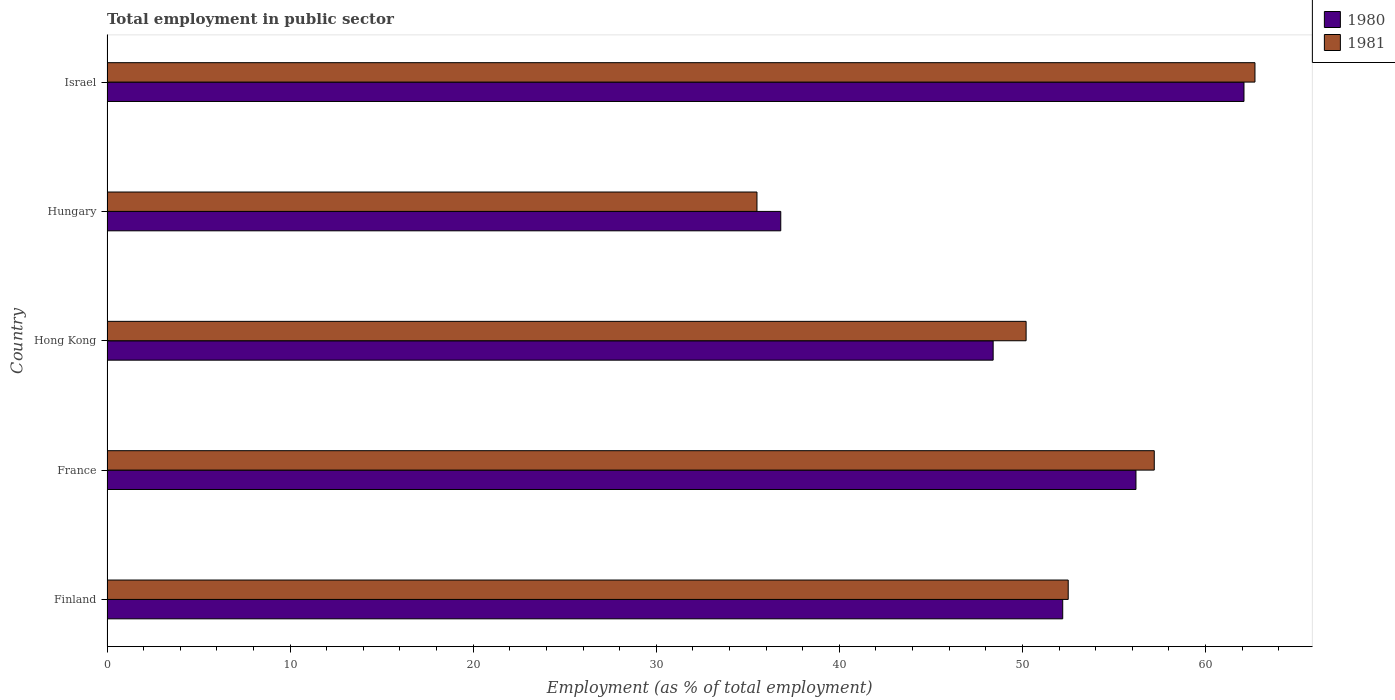Are the number of bars on each tick of the Y-axis equal?
Give a very brief answer. Yes. How many bars are there on the 2nd tick from the top?
Provide a short and direct response. 2. What is the label of the 3rd group of bars from the top?
Offer a terse response. Hong Kong. What is the employment in public sector in 1980 in Hong Kong?
Make the answer very short. 48.4. Across all countries, what is the maximum employment in public sector in 1980?
Your answer should be compact. 62.1. Across all countries, what is the minimum employment in public sector in 1980?
Ensure brevity in your answer.  36.8. In which country was the employment in public sector in 1981 maximum?
Provide a short and direct response. Israel. In which country was the employment in public sector in 1980 minimum?
Provide a succinct answer. Hungary. What is the total employment in public sector in 1981 in the graph?
Offer a terse response. 258.1. What is the difference between the employment in public sector in 1981 in Hong Kong and the employment in public sector in 1980 in Hungary?
Your answer should be very brief. 13.4. What is the average employment in public sector in 1981 per country?
Your answer should be compact. 51.62. In how many countries, is the employment in public sector in 1981 greater than 20 %?
Provide a short and direct response. 5. What is the ratio of the employment in public sector in 1980 in Hong Kong to that in Hungary?
Provide a succinct answer. 1.32. Is the employment in public sector in 1981 in Finland less than that in France?
Your answer should be compact. Yes. Is the difference between the employment in public sector in 1981 in Hong Kong and Hungary greater than the difference between the employment in public sector in 1980 in Hong Kong and Hungary?
Make the answer very short. Yes. What is the difference between the highest and the lowest employment in public sector in 1980?
Your response must be concise. 25.3. Is the sum of the employment in public sector in 1981 in France and Hungary greater than the maximum employment in public sector in 1980 across all countries?
Provide a succinct answer. Yes. What does the 1st bar from the top in France represents?
Provide a succinct answer. 1981. What does the 2nd bar from the bottom in Finland represents?
Provide a succinct answer. 1981. How many countries are there in the graph?
Keep it short and to the point. 5. What is the difference between two consecutive major ticks on the X-axis?
Your response must be concise. 10. Does the graph contain any zero values?
Ensure brevity in your answer.  No. Where does the legend appear in the graph?
Offer a terse response. Top right. What is the title of the graph?
Make the answer very short. Total employment in public sector. What is the label or title of the X-axis?
Your answer should be very brief. Employment (as % of total employment). What is the Employment (as % of total employment) of 1980 in Finland?
Make the answer very short. 52.2. What is the Employment (as % of total employment) of 1981 in Finland?
Your answer should be compact. 52.5. What is the Employment (as % of total employment) of 1980 in France?
Offer a terse response. 56.2. What is the Employment (as % of total employment) in 1981 in France?
Your answer should be very brief. 57.2. What is the Employment (as % of total employment) in 1980 in Hong Kong?
Provide a succinct answer. 48.4. What is the Employment (as % of total employment) in 1981 in Hong Kong?
Make the answer very short. 50.2. What is the Employment (as % of total employment) of 1980 in Hungary?
Provide a succinct answer. 36.8. What is the Employment (as % of total employment) of 1981 in Hungary?
Offer a very short reply. 35.5. What is the Employment (as % of total employment) in 1980 in Israel?
Your answer should be compact. 62.1. What is the Employment (as % of total employment) in 1981 in Israel?
Your answer should be compact. 62.7. Across all countries, what is the maximum Employment (as % of total employment) of 1980?
Provide a succinct answer. 62.1. Across all countries, what is the maximum Employment (as % of total employment) of 1981?
Your response must be concise. 62.7. Across all countries, what is the minimum Employment (as % of total employment) in 1980?
Provide a succinct answer. 36.8. Across all countries, what is the minimum Employment (as % of total employment) in 1981?
Ensure brevity in your answer.  35.5. What is the total Employment (as % of total employment) in 1980 in the graph?
Your response must be concise. 255.7. What is the total Employment (as % of total employment) in 1981 in the graph?
Your response must be concise. 258.1. What is the difference between the Employment (as % of total employment) in 1980 in Finland and that in France?
Provide a short and direct response. -4. What is the difference between the Employment (as % of total employment) of 1980 in Finland and that in Hungary?
Offer a very short reply. 15.4. What is the difference between the Employment (as % of total employment) of 1981 in Finland and that in Hungary?
Your answer should be very brief. 17. What is the difference between the Employment (as % of total employment) in 1981 in France and that in Hungary?
Provide a succinct answer. 21.7. What is the difference between the Employment (as % of total employment) in 1981 in France and that in Israel?
Your response must be concise. -5.5. What is the difference between the Employment (as % of total employment) of 1980 in Hong Kong and that in Israel?
Provide a short and direct response. -13.7. What is the difference between the Employment (as % of total employment) of 1981 in Hong Kong and that in Israel?
Your answer should be very brief. -12.5. What is the difference between the Employment (as % of total employment) of 1980 in Hungary and that in Israel?
Offer a very short reply. -25.3. What is the difference between the Employment (as % of total employment) in 1981 in Hungary and that in Israel?
Ensure brevity in your answer.  -27.2. What is the difference between the Employment (as % of total employment) in 1980 in Finland and the Employment (as % of total employment) in 1981 in Hong Kong?
Give a very brief answer. 2. What is the difference between the Employment (as % of total employment) in 1980 in Finland and the Employment (as % of total employment) in 1981 in Israel?
Your answer should be very brief. -10.5. What is the difference between the Employment (as % of total employment) of 1980 in France and the Employment (as % of total employment) of 1981 in Hungary?
Your answer should be compact. 20.7. What is the difference between the Employment (as % of total employment) in 1980 in France and the Employment (as % of total employment) in 1981 in Israel?
Offer a terse response. -6.5. What is the difference between the Employment (as % of total employment) of 1980 in Hong Kong and the Employment (as % of total employment) of 1981 in Hungary?
Ensure brevity in your answer.  12.9. What is the difference between the Employment (as % of total employment) in 1980 in Hong Kong and the Employment (as % of total employment) in 1981 in Israel?
Keep it short and to the point. -14.3. What is the difference between the Employment (as % of total employment) of 1980 in Hungary and the Employment (as % of total employment) of 1981 in Israel?
Keep it short and to the point. -25.9. What is the average Employment (as % of total employment) in 1980 per country?
Make the answer very short. 51.14. What is the average Employment (as % of total employment) in 1981 per country?
Offer a terse response. 51.62. What is the difference between the Employment (as % of total employment) in 1980 and Employment (as % of total employment) in 1981 in Hungary?
Your answer should be compact. 1.3. What is the difference between the Employment (as % of total employment) of 1980 and Employment (as % of total employment) of 1981 in Israel?
Ensure brevity in your answer.  -0.6. What is the ratio of the Employment (as % of total employment) of 1980 in Finland to that in France?
Give a very brief answer. 0.93. What is the ratio of the Employment (as % of total employment) in 1981 in Finland to that in France?
Your answer should be compact. 0.92. What is the ratio of the Employment (as % of total employment) in 1980 in Finland to that in Hong Kong?
Your response must be concise. 1.08. What is the ratio of the Employment (as % of total employment) in 1981 in Finland to that in Hong Kong?
Your response must be concise. 1.05. What is the ratio of the Employment (as % of total employment) in 1980 in Finland to that in Hungary?
Provide a succinct answer. 1.42. What is the ratio of the Employment (as % of total employment) of 1981 in Finland to that in Hungary?
Provide a succinct answer. 1.48. What is the ratio of the Employment (as % of total employment) in 1980 in Finland to that in Israel?
Give a very brief answer. 0.84. What is the ratio of the Employment (as % of total employment) in 1981 in Finland to that in Israel?
Make the answer very short. 0.84. What is the ratio of the Employment (as % of total employment) of 1980 in France to that in Hong Kong?
Your response must be concise. 1.16. What is the ratio of the Employment (as % of total employment) in 1981 in France to that in Hong Kong?
Offer a very short reply. 1.14. What is the ratio of the Employment (as % of total employment) in 1980 in France to that in Hungary?
Offer a very short reply. 1.53. What is the ratio of the Employment (as % of total employment) of 1981 in France to that in Hungary?
Provide a short and direct response. 1.61. What is the ratio of the Employment (as % of total employment) in 1980 in France to that in Israel?
Give a very brief answer. 0.91. What is the ratio of the Employment (as % of total employment) of 1981 in France to that in Israel?
Give a very brief answer. 0.91. What is the ratio of the Employment (as % of total employment) in 1980 in Hong Kong to that in Hungary?
Keep it short and to the point. 1.32. What is the ratio of the Employment (as % of total employment) of 1981 in Hong Kong to that in Hungary?
Your response must be concise. 1.41. What is the ratio of the Employment (as % of total employment) of 1980 in Hong Kong to that in Israel?
Give a very brief answer. 0.78. What is the ratio of the Employment (as % of total employment) in 1981 in Hong Kong to that in Israel?
Provide a short and direct response. 0.8. What is the ratio of the Employment (as % of total employment) in 1980 in Hungary to that in Israel?
Make the answer very short. 0.59. What is the ratio of the Employment (as % of total employment) of 1981 in Hungary to that in Israel?
Ensure brevity in your answer.  0.57. What is the difference between the highest and the second highest Employment (as % of total employment) in 1980?
Your response must be concise. 5.9. What is the difference between the highest and the lowest Employment (as % of total employment) of 1980?
Provide a succinct answer. 25.3. What is the difference between the highest and the lowest Employment (as % of total employment) in 1981?
Make the answer very short. 27.2. 